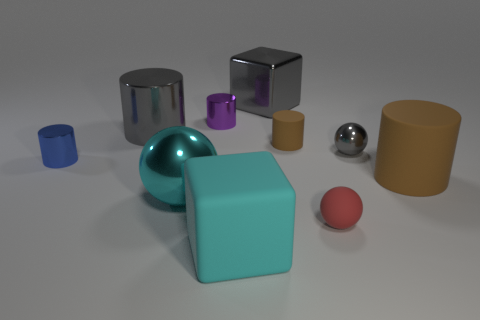Subtract all tiny red rubber balls. How many balls are left? 2 Subtract all gray spheres. How many spheres are left? 2 Subtract all brown balls. How many gray cylinders are left? 1 Subtract all blocks. How many objects are left? 8 Subtract 3 cylinders. How many cylinders are left? 2 Subtract all green cylinders. Subtract all cyan spheres. How many cylinders are left? 5 Subtract all brown spheres. Subtract all gray metal objects. How many objects are left? 7 Add 8 big cyan metal balls. How many big cyan metal balls are left? 9 Add 6 big red matte balls. How many big red matte balls exist? 6 Subtract 0 brown spheres. How many objects are left? 10 